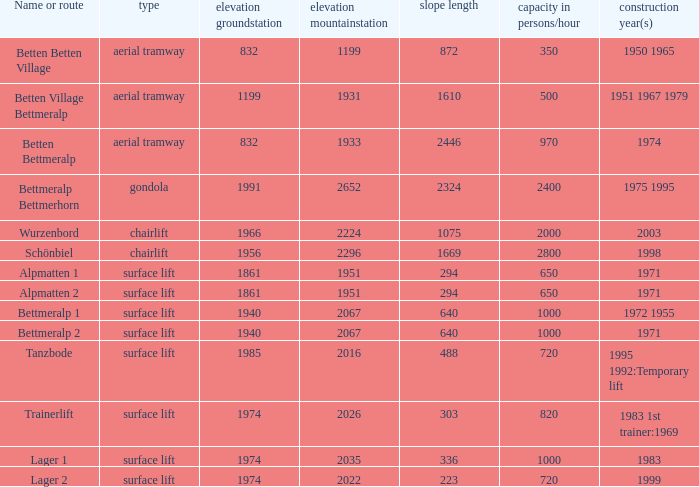Which slope length has a type of surface lift, and an elevation groundstation smaller than 1974, and a construction year(s) of 1971, and a Name or route of alpmatten 1? 294.0. 